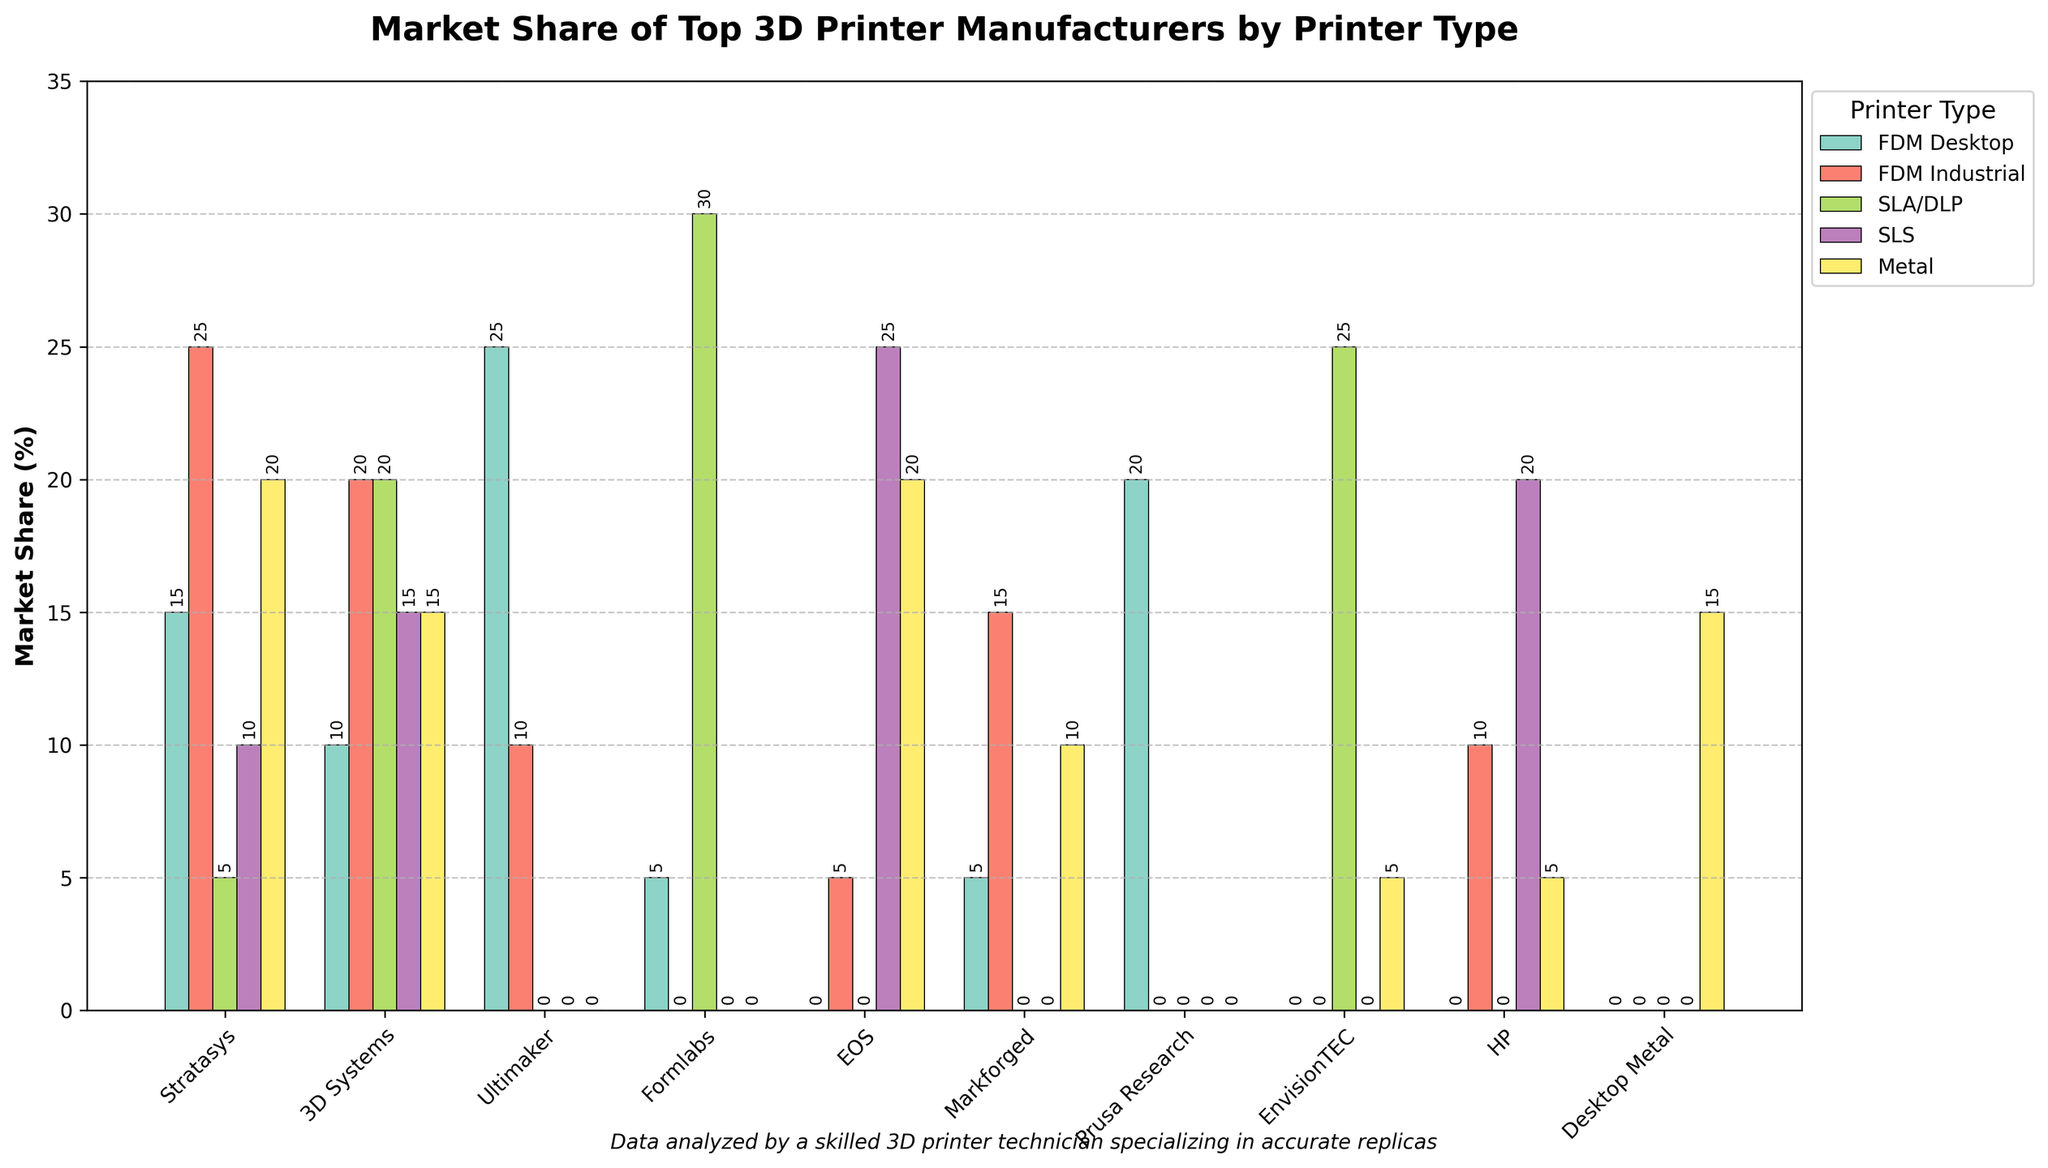What is the total market share for Stratasys? To find the total market share for Stratasys, sum the market share percentages for all printer types: (15 + 25 + 5 + 10 + 20) = 75
Answer: 75 Which manufacturer has the highest market share in FDM Desktop printers? Look for the highest value in the FDM Desktop column. Ultimaker has a market share of 25%, which is the highest.
Answer: Ultimaker Which printer type has the smallest market share for HP? Compare the bars corresponding to HP across all printer types. HP has zero market share in FDM Desktop, SLA/DLP, and Metal, but only zero market share can be considered the smallest.
Answer: SLA/DLP How does the market share for Formlabs in SLA/DLP compare with Stratasys in the same category? Formlabs has a 30% market share in SLA/DLP, while Stratasys has a 5% market share in the same category. 30% is significantly higher than 5%.
Answer: Higher What is the average market share for EOS across all printer types? Sum the market shares for EOS (0, 5, 0, 25, 20) and divide by the number of printer types: (0 + 5 + 0 + 25 + 20) / 5 = 50 / 5 = 10
Answer: 10 Which manufacturer has the greater market share in Metal printers, Markforged or Desktop Metal? Markforged has a market share of 10% in Metal printers while Desktop Metal has 15%. So, Desktop Metal has a greater share.
Answer: Desktop Metal Between 3D Systems and EnvisionTEC, who has a higher overall market share in SLA/DLP printers? Compare the SLA/DLP market share for these manufacturers: 3D Systems has a 20% share, and EnvisionTEC has a 25% share. EnvisionTEC has a higher share.
Answer: EnvisionTEC How does the market share in SLS printers for Stratasys compare with HP? Stratasys has a 10% market share in SLS printers, while HP has a 20% share. HP's share is higher than Stratasys.
Answer: Higher What is the combined market share for Ultimaker and Prusa Research in FDM Desktop printers? Combine their market shares for FDM Desktop: Ultimaker (25%) + Prusa Research (20%) = 45%
Answer: 45 Which manufacturer has the least market share in FDM Industrial printers? Look for the smallest value in the FDM Industrial column. Both Formlabs and Prusa Research have a 0% market share, which is the least.
Answer: Formlabs, Prusa Research 